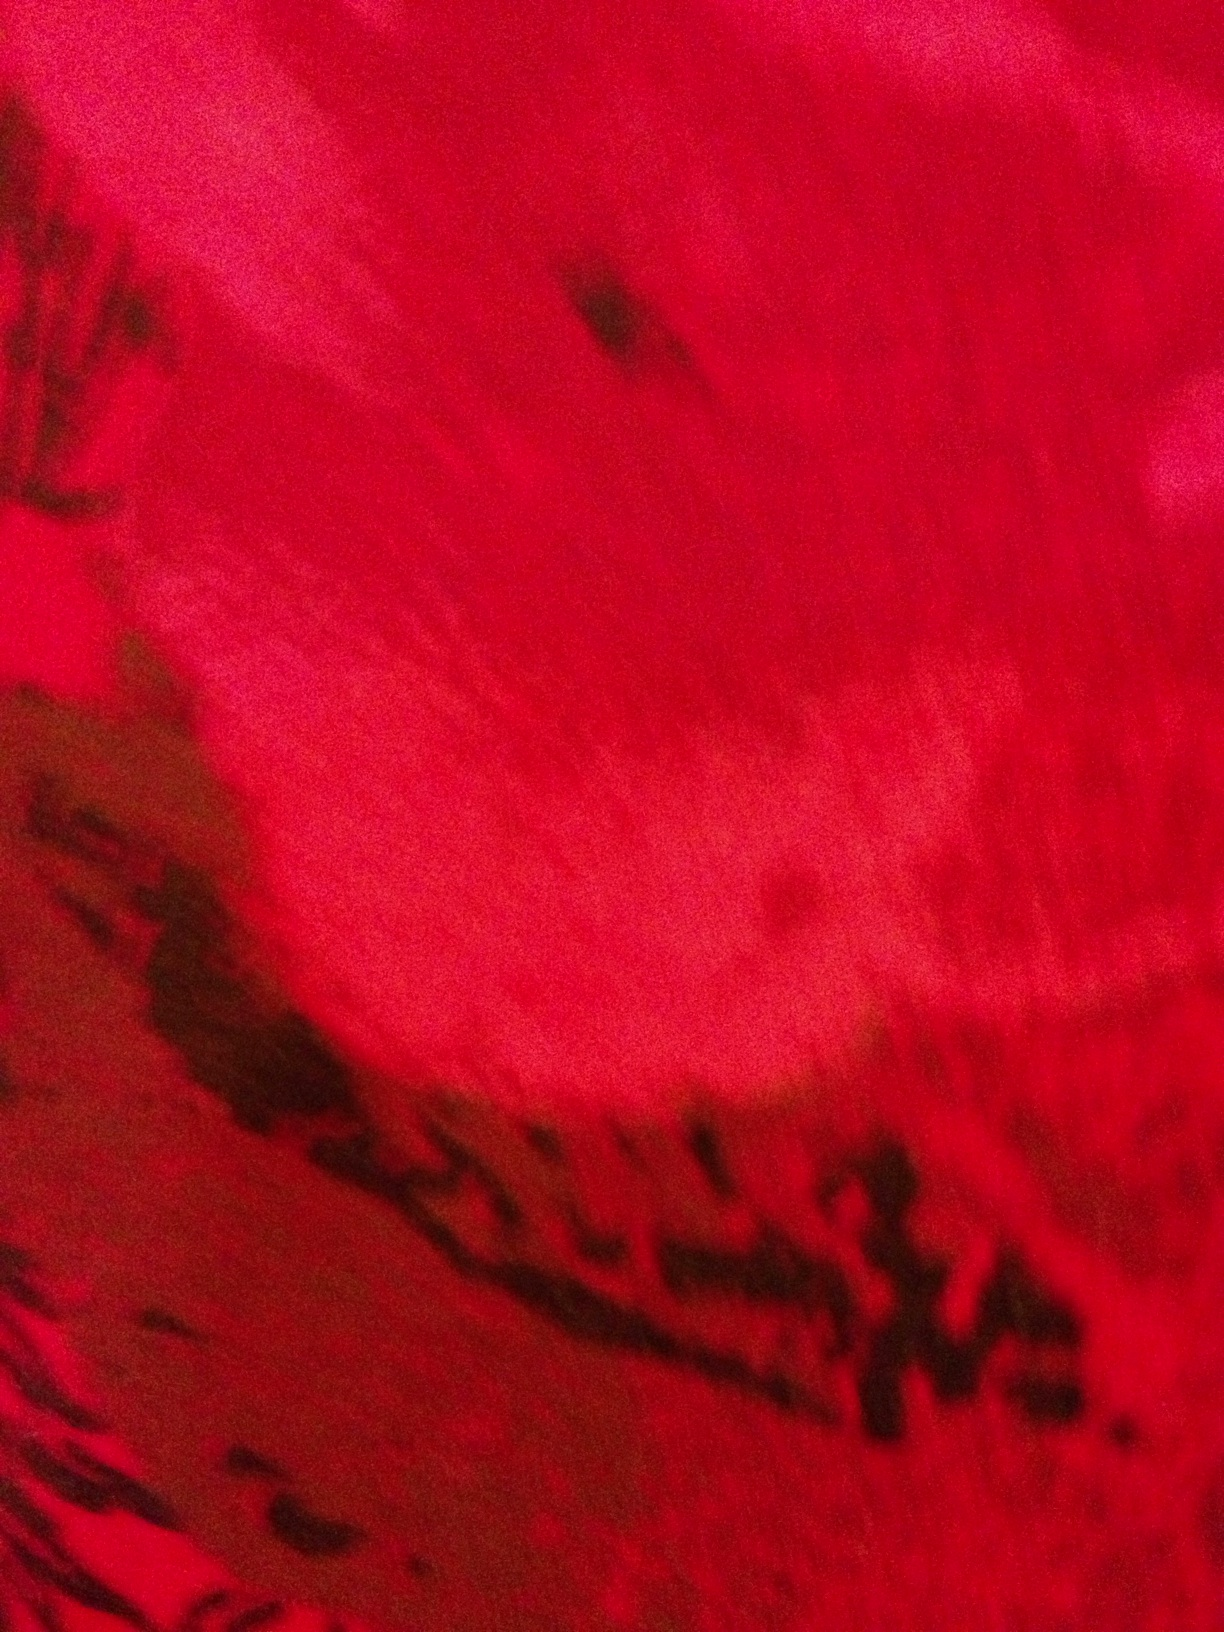Can you describe a scene that this image might be a part of? This image could be part of a lush garden during a warm summer evening. The sun is setting, casting a rich, warm glow over the vibrant red petals of various flowers. The interplay of light and shadow dances gently on the delicate surfaces, creating an enchanting and serene atmosphere. What might be the mood of this garden scene? The mood of this garden scene would be tranquil and romantic, with a sense of peace and natural beauty. The warmth of the sunset combined with the vivid colors of the flowers creates a soothing and almost magical ambiance, perfect for a quiet evening stroll or a moment of reflection. Imagine a story where this garden plays a central role. In a secluded corner of the kingdom, there lies a mysterious garden, known only to a few. It is said that this garden was tended by an ancient guardian spirit, who infused the flowers with their magic. One day, a young traveler stumbled upon this hidden paradise. As they wandered among the vibrant flowers, they happened upon a red petal that shimmered with an otherworldly glow. This petal held the key to an ancient prophecy, one that spoke of a hero who would restore harmony to the land. The traveler, guided by the whispers of the guardian spirit, embarks on a quest that would take them through enchanted forests, across mystical lands, and into the heart of an age-old mystery, with the garden always leading them back home. 